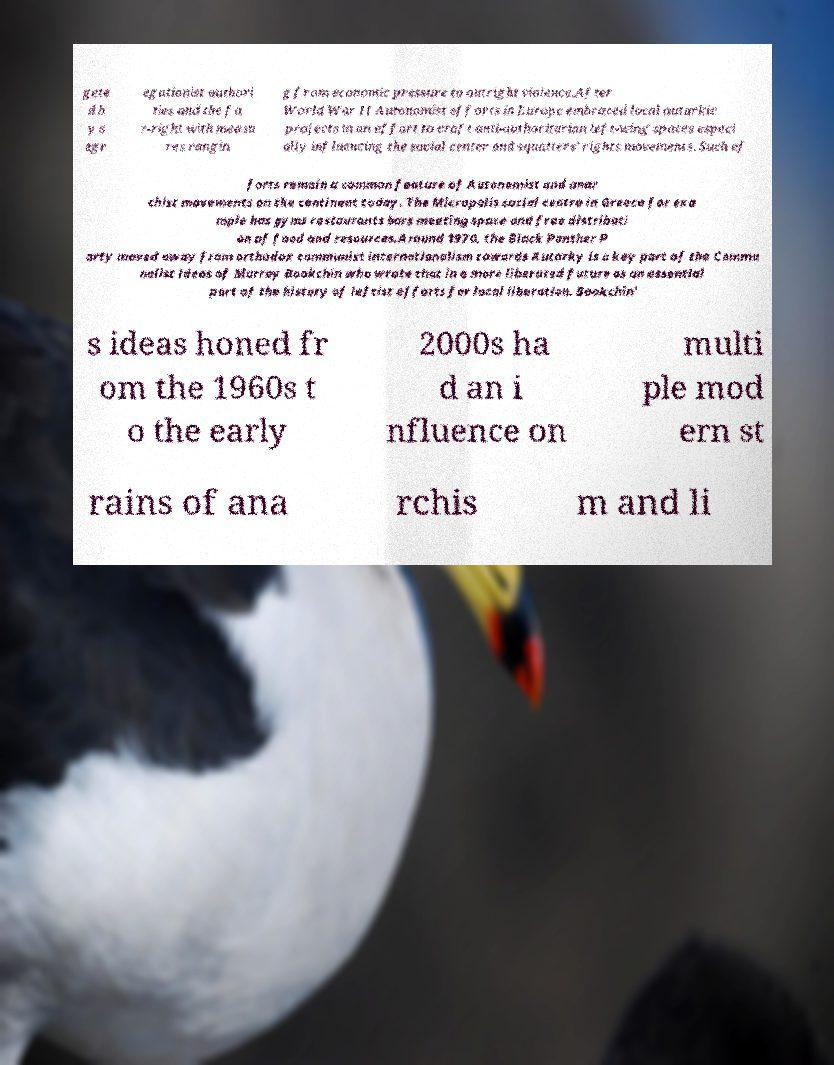Could you assist in decoding the text presented in this image and type it out clearly? gete d b y s egr egationist authori ties and the fa r-right with measu res rangin g from economic pressure to outright violence.After World War II Autonomist efforts in Europe embraced local autarkic projects in an effort to craft anti-authoritarian left-wing spaces especi ally influencing the social center and squatters' rights movements. Such ef forts remain a common feature of Autonomist and anar chist movements on the continent today. The Micropolis social centre in Greece for exa mple has gyms restaurants bars meeting space and free distributi on of food and resources.Around 1970, the Black Panther P arty moved away from orthodox communist internationalism towards Autarky is a key part of the Commu nalist ideas of Murray Bookchin who wrote that in a more liberated future as an essential part of the history of leftist efforts for local liberation. Bookchin' s ideas honed fr om the 1960s t o the early 2000s ha d an i nfluence on multi ple mod ern st rains of ana rchis m and li 